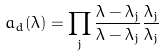Convert formula to latex. <formula><loc_0><loc_0><loc_500><loc_500>a _ { d } ( \lambda ) = \prod _ { j } \frac { \lambda - \lambda _ { j } } { \lambda - \bar { \lambda } _ { j } } \frac { \bar { \lambda } _ { j } } { \lambda _ { j } }</formula> 